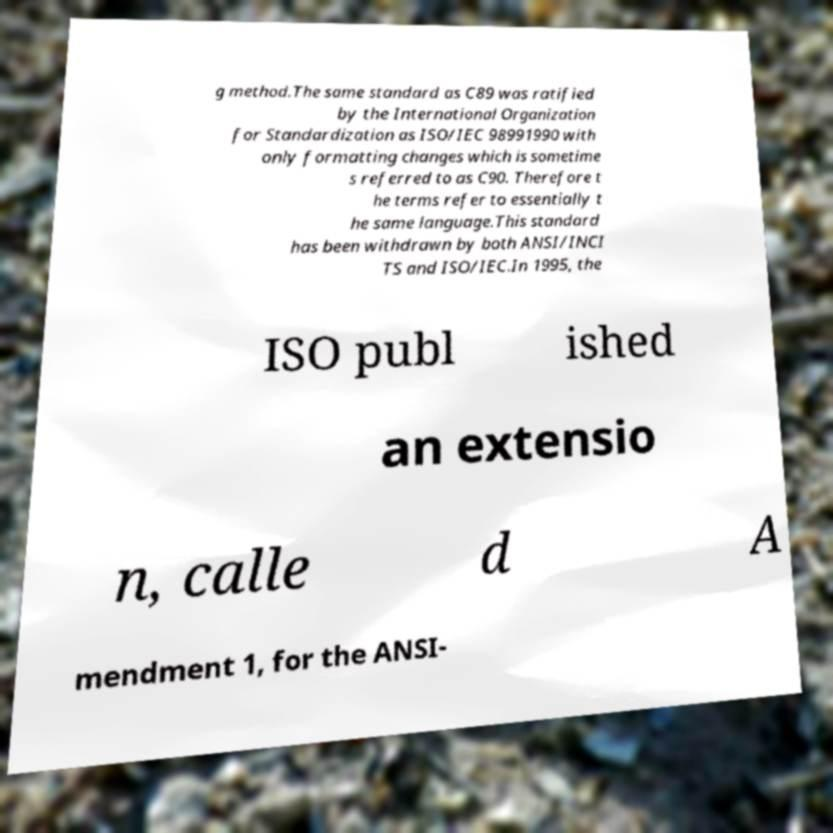There's text embedded in this image that I need extracted. Can you transcribe it verbatim? g method.The same standard as C89 was ratified by the International Organization for Standardization as ISO/IEC 98991990 with only formatting changes which is sometime s referred to as C90. Therefore t he terms refer to essentially t he same language.This standard has been withdrawn by both ANSI/INCI TS and ISO/IEC.In 1995, the ISO publ ished an extensio n, calle d A mendment 1, for the ANSI- 